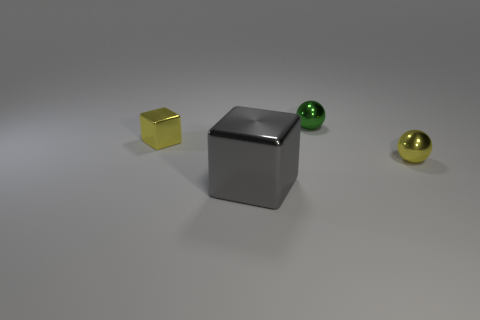Add 4 tiny yellow cubes. How many objects exist? 8 Subtract all gray cubes. How many cubes are left? 1 Subtract all tiny purple shiny objects. Subtract all small yellow things. How many objects are left? 2 Add 2 tiny green shiny balls. How many tiny green shiny balls are left? 3 Add 1 tiny yellow objects. How many tiny yellow objects exist? 3 Subtract 0 blue cylinders. How many objects are left? 4 Subtract all gray spheres. Subtract all brown cylinders. How many spheres are left? 2 